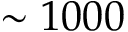<formula> <loc_0><loc_0><loc_500><loc_500>\sim 1 0 0 0</formula> 